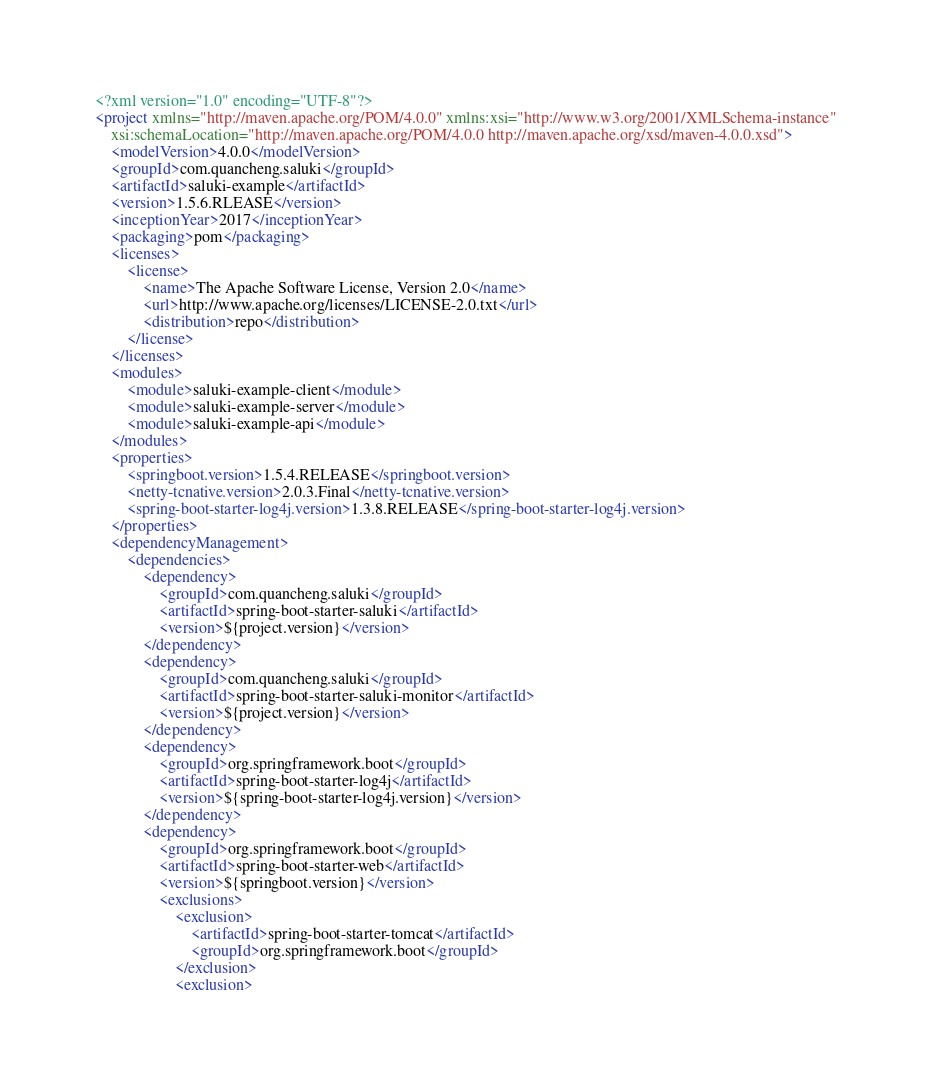<code> <loc_0><loc_0><loc_500><loc_500><_XML_><?xml version="1.0" encoding="UTF-8"?>
<project xmlns="http://maven.apache.org/POM/4.0.0" xmlns:xsi="http://www.w3.org/2001/XMLSchema-instance"
	xsi:schemaLocation="http://maven.apache.org/POM/4.0.0 http://maven.apache.org/xsd/maven-4.0.0.xsd">
	<modelVersion>4.0.0</modelVersion>
	<groupId>com.quancheng.saluki</groupId>
	<artifactId>saluki-example</artifactId>
	<version>1.5.6.RLEASE</version>
	<inceptionYear>2017</inceptionYear>
	<packaging>pom</packaging>
	<licenses>
		<license>
			<name>The Apache Software License, Version 2.0</name>
			<url>http://www.apache.org/licenses/LICENSE-2.0.txt</url>
			<distribution>repo</distribution>
		</license>
	</licenses>
	<modules>
		<module>saluki-example-client</module>
		<module>saluki-example-server</module>
		<module>saluki-example-api</module>
	</modules>
	<properties>
		<springboot.version>1.5.4.RELEASE</springboot.version>
		<netty-tcnative.version>2.0.3.Final</netty-tcnative.version>
		<spring-boot-starter-log4j.version>1.3.8.RELEASE</spring-boot-starter-log4j.version>
	</properties>
	<dependencyManagement>
		<dependencies>
			<dependency>
				<groupId>com.quancheng.saluki</groupId>
				<artifactId>spring-boot-starter-saluki</artifactId>
				<version>${project.version}</version>
			</dependency>
			<dependency>
				<groupId>com.quancheng.saluki</groupId>
				<artifactId>spring-boot-starter-saluki-monitor</artifactId>
				<version>${project.version}</version>
			</dependency>
			<dependency>
				<groupId>org.springframework.boot</groupId>
				<artifactId>spring-boot-starter-log4j</artifactId>
				<version>${spring-boot-starter-log4j.version}</version>
			</dependency>
			<dependency>
				<groupId>org.springframework.boot</groupId>
				<artifactId>spring-boot-starter-web</artifactId>
				<version>${springboot.version}</version>
				<exclusions>
					<exclusion>
						<artifactId>spring-boot-starter-tomcat</artifactId>
						<groupId>org.springframework.boot</groupId>
					</exclusion>
					<exclusion></code> 